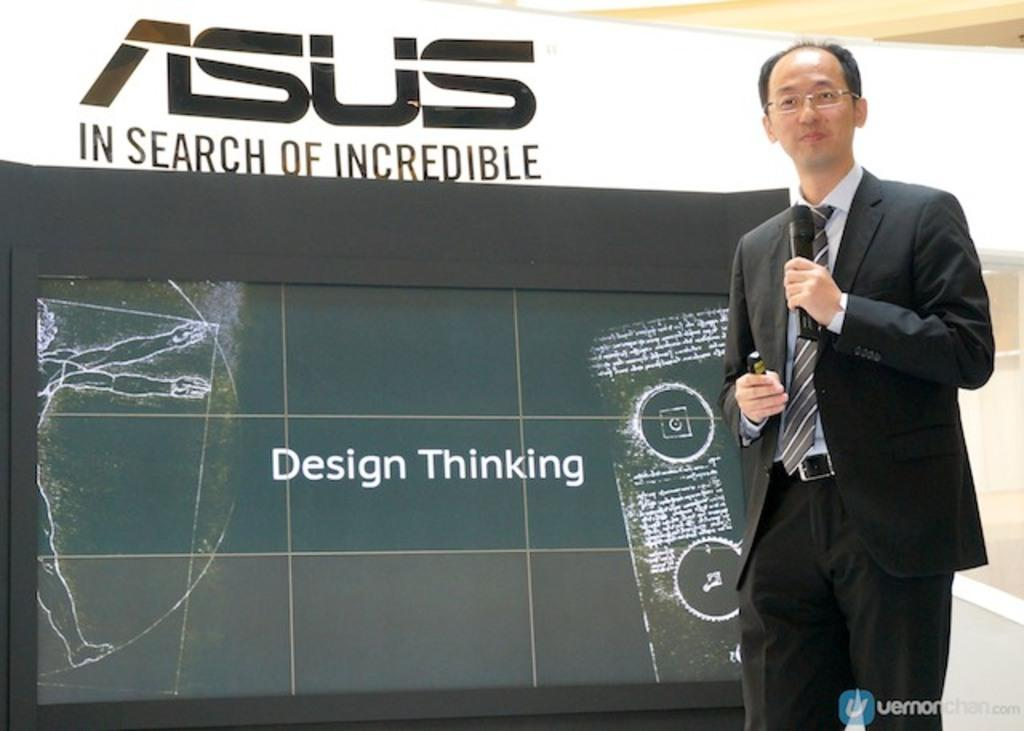What is the man in the image holding? The man is holding a microphone. Can you describe the man's appearance in the image? The man is wearing spectacles. What can be seen in the background of the image? There is a screen and a banner in the background of the image. Is there any additional information or branding present in the image? Yes, there is a watermark at the bottom of the image. What type of bean is depicted on the man's locket in the image? There is no locket or bean present in the image. 